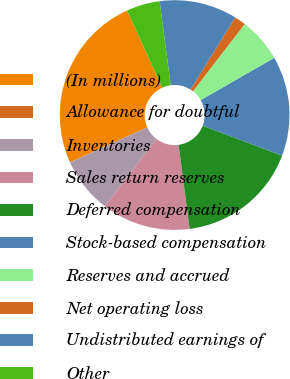Convert chart. <chart><loc_0><loc_0><loc_500><loc_500><pie_chart><fcel>(In millions)<fcel>Allowance for doubtful<fcel>Inventories<fcel>Sales return reserves<fcel>Deferred compensation<fcel>Stock-based compensation<fcel>Reserves and accrued<fcel>Net operating loss<fcel>Undistributed earnings of<fcel>Other<nl><fcel>24.94%<fcel>0.04%<fcel>7.82%<fcel>12.49%<fcel>17.16%<fcel>14.05%<fcel>6.26%<fcel>1.6%<fcel>10.93%<fcel>4.71%<nl></chart> 